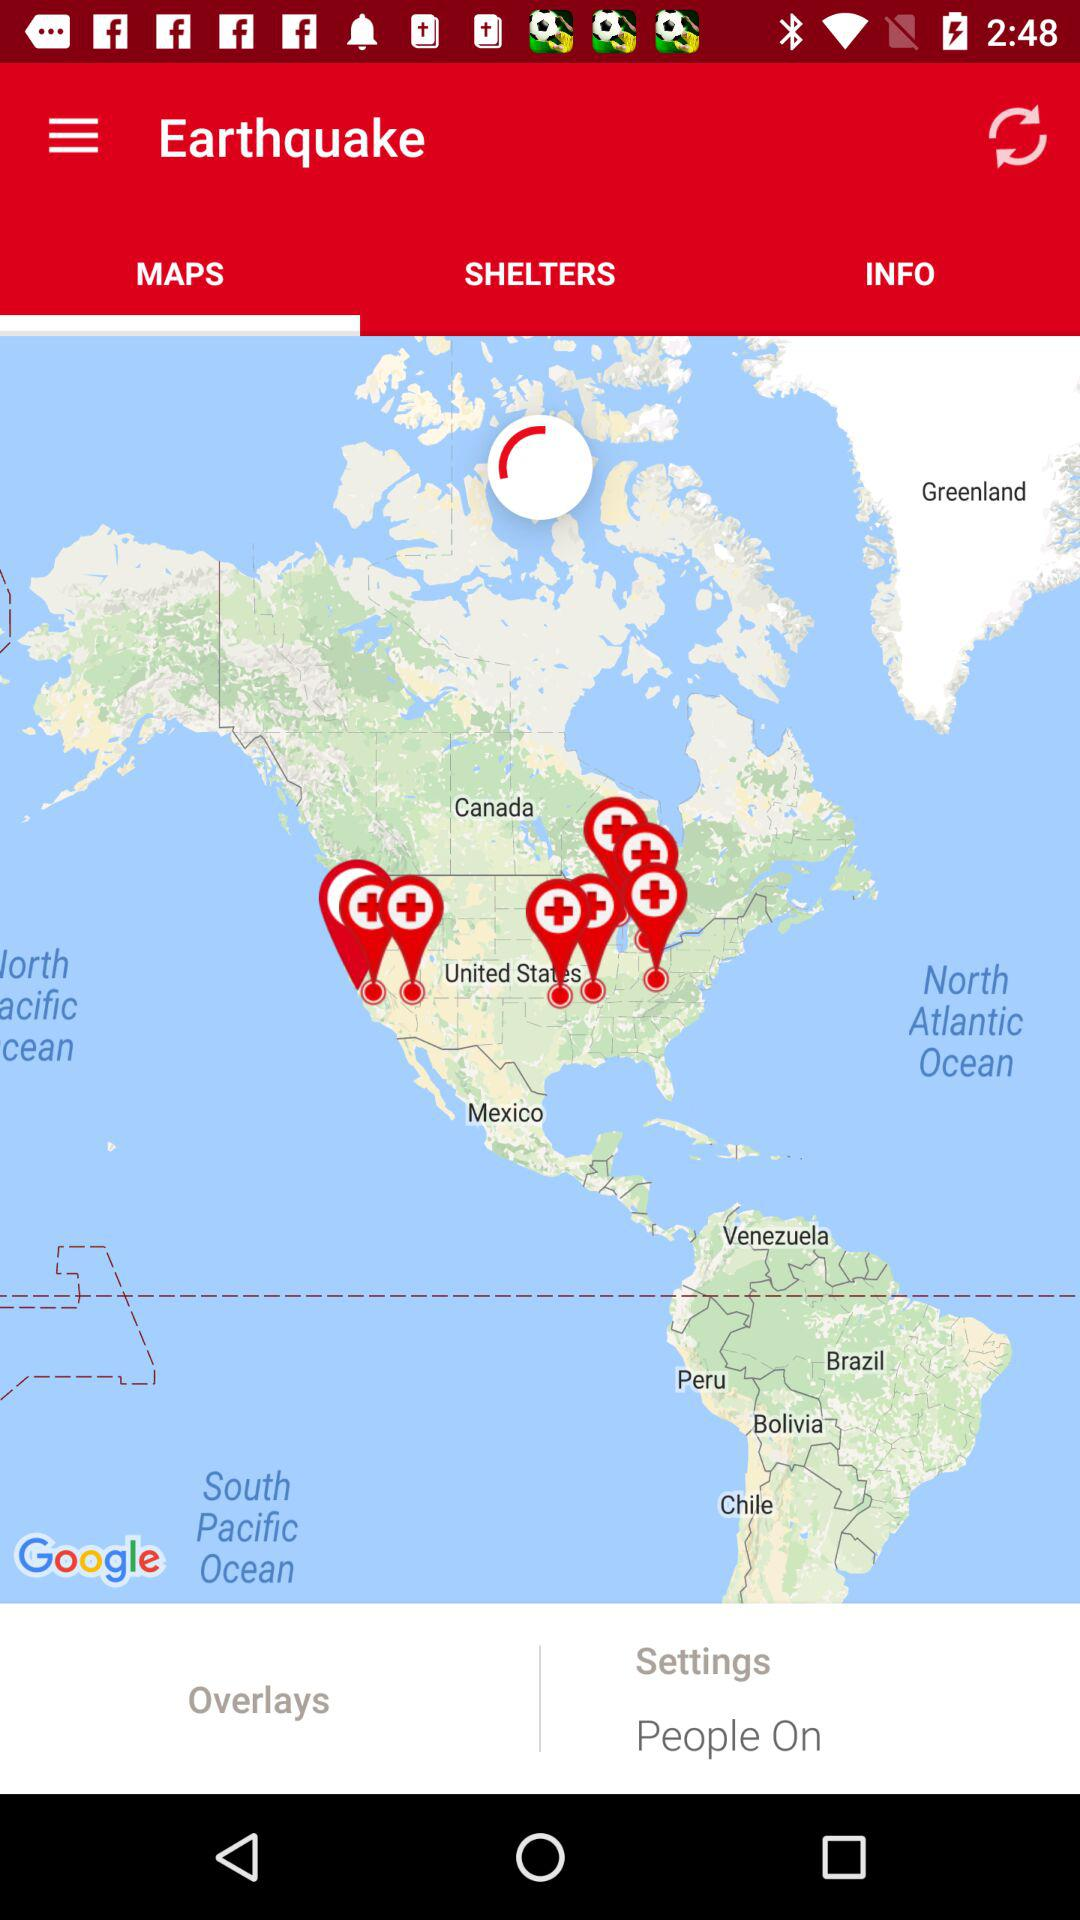Which tab is selected? The selected tab is "Maps". 